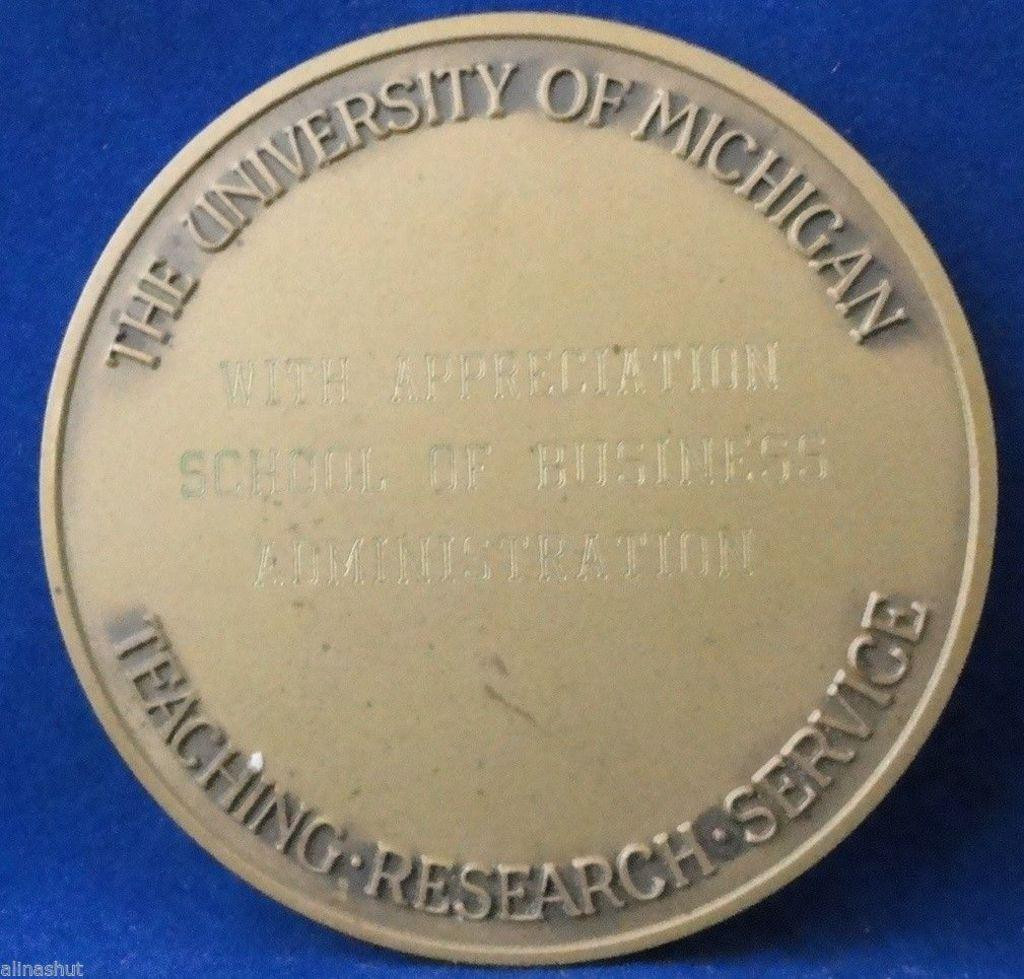Provide a one-sentence caption for the provided image. A medallion from the University of Michigan is on display on a blue background. 